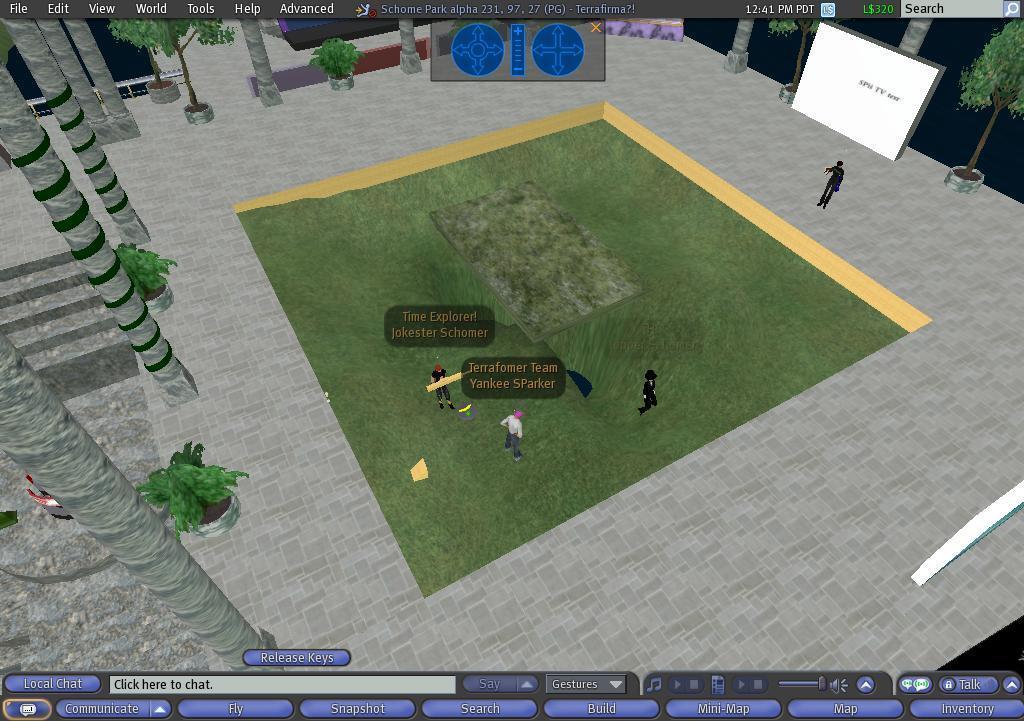How would you summarize this image in a sentence or two? This is an animated image. At the bottom of this image, there are menus. On the left side, there are poles, potted plants and steps. In the middle of this image, there are persons playing on the ground. On the right side, there are screen arranged, a person standing, there are trees and poles. And the background is dark in color. 